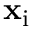<formula> <loc_0><loc_0><loc_500><loc_500>x _ { i }</formula> 